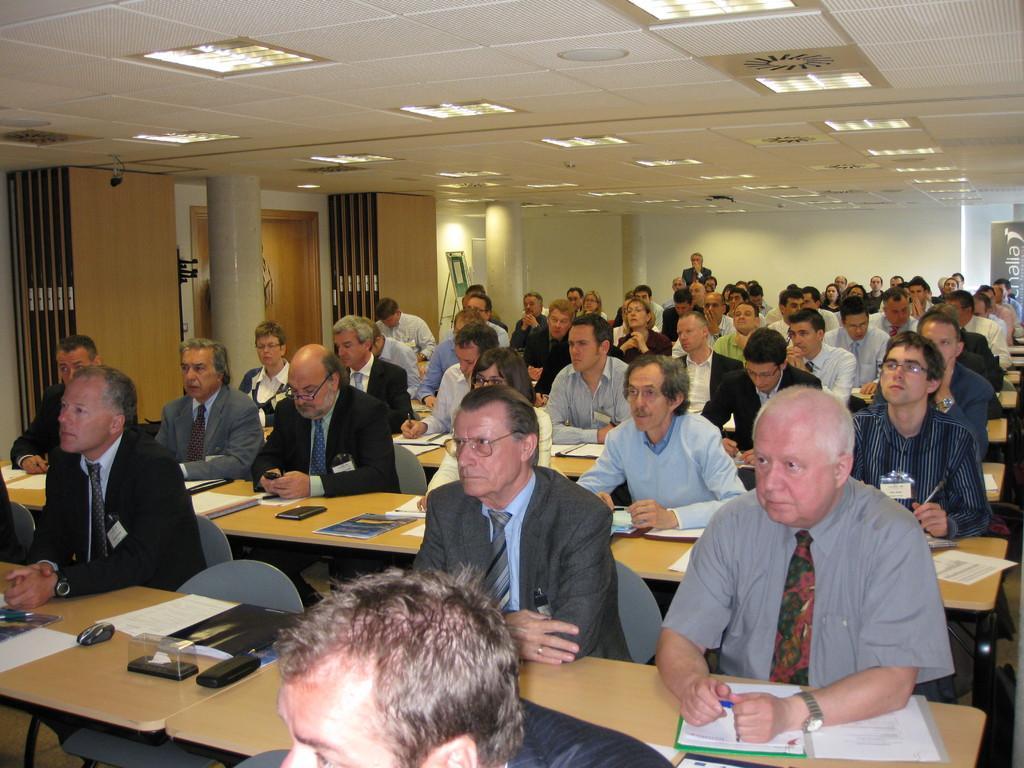In one or two sentences, can you explain what this image depicts? The image is taken inside a room. There are many people sitting on a chair. There are tables. There are books, pens papers placed on a table. There are chairs. There is a pillar. On the top of the roof there are lights in the background there is a wall and a board. 